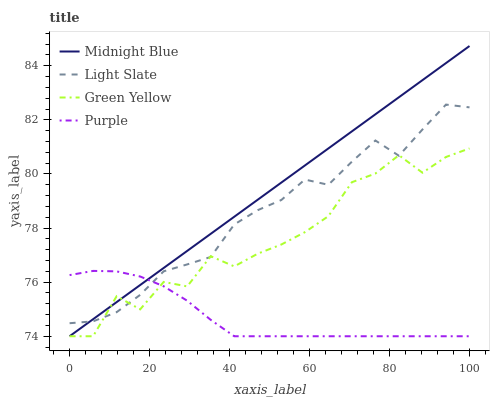Does Green Yellow have the minimum area under the curve?
Answer yes or no. No. Does Green Yellow have the maximum area under the curve?
Answer yes or no. No. Is Purple the smoothest?
Answer yes or no. No. Is Purple the roughest?
Answer yes or no. No. Does Green Yellow have the highest value?
Answer yes or no. No. 